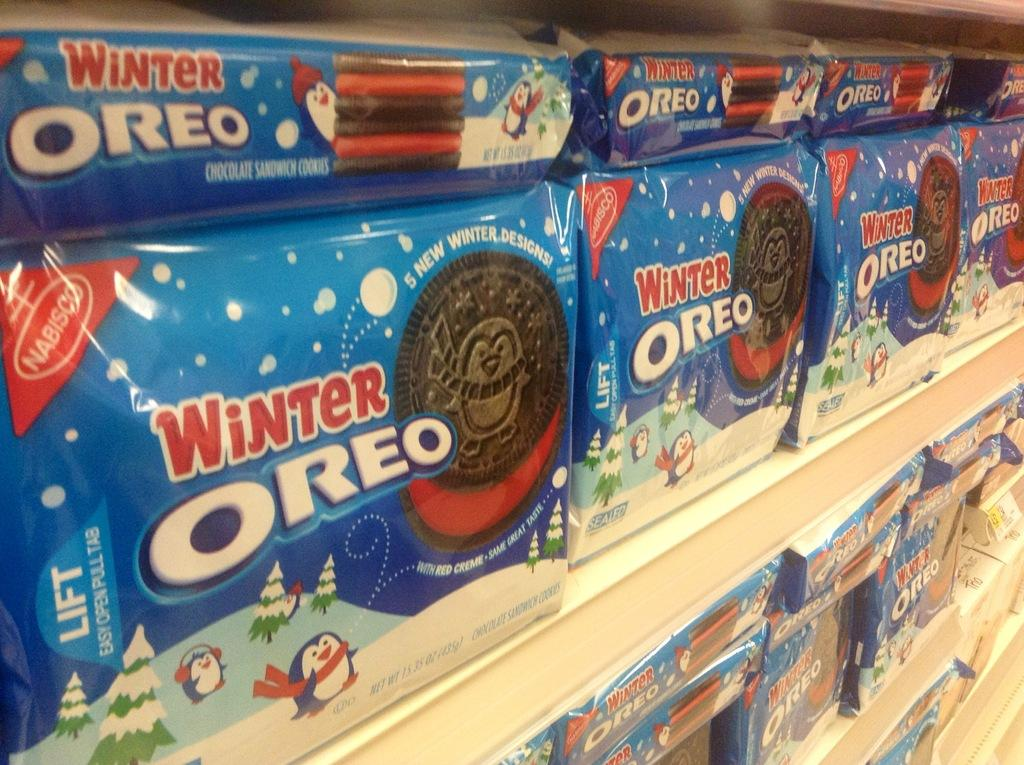What can be seen in the image that is used for storage? There are racks in the image that are used for storage. What type of items are stored on the racks? The racks contain biscuit packets. How can you identify the different types of biscuit packets? The biscuit packets have labels with text written on them. What type of news can be seen on the labels of the biscuit packets? There is no news present on the labels of the biscuit packets; they only contain information about the biscuits. What is the condition of the sleet in the image? There is no sleet present in the image; it is an indoor setting with racks and biscuit packets. 